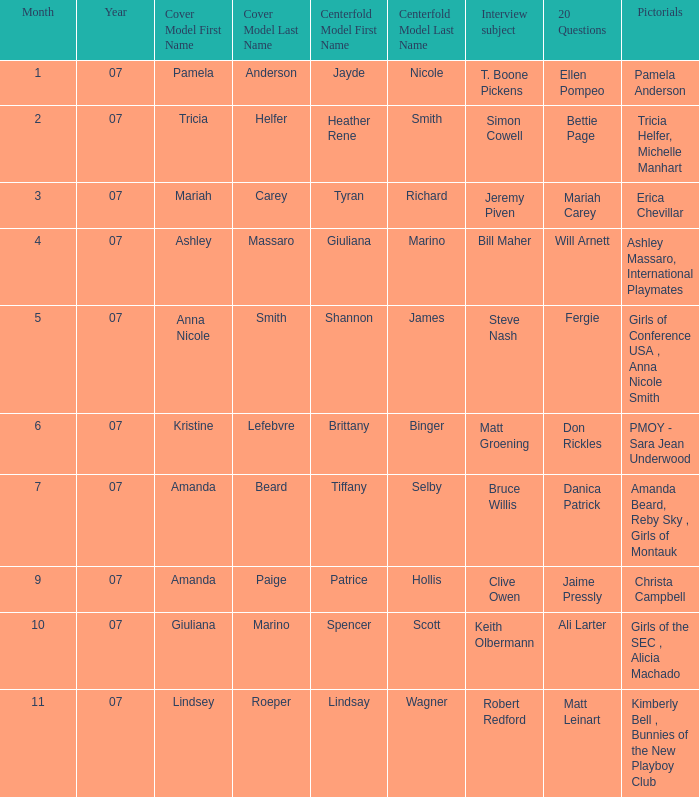Who was the centerfold model in the issue where Fergie answered the "20 questions"? Shannon James. 